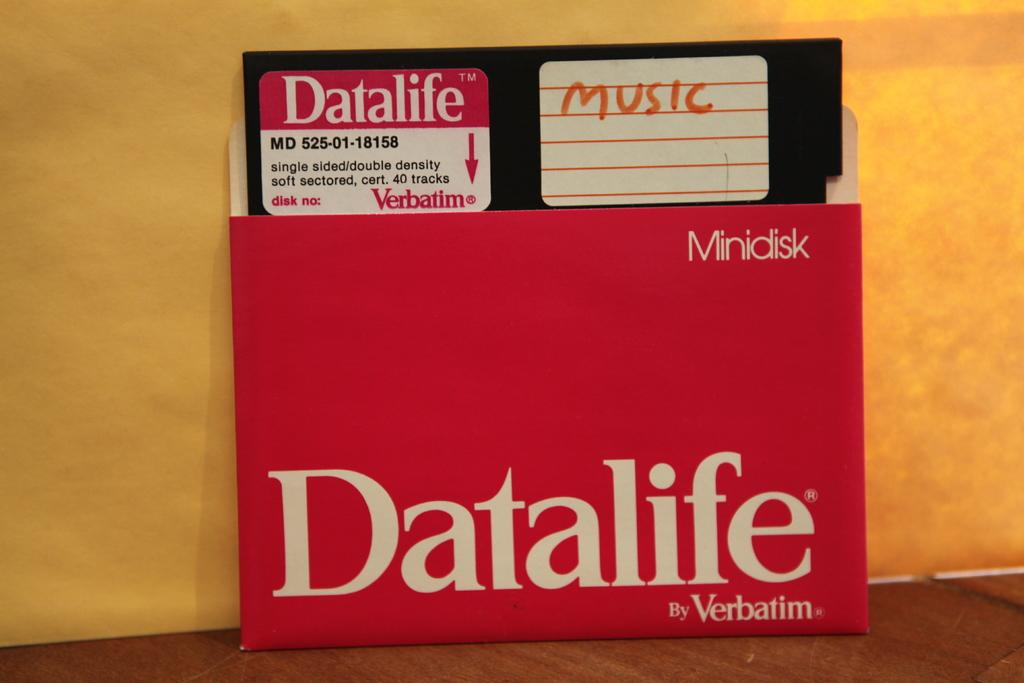<image>
Render a clear and concise summary of the photo. A red box that reads "datalife" holds a disc titled "music." 